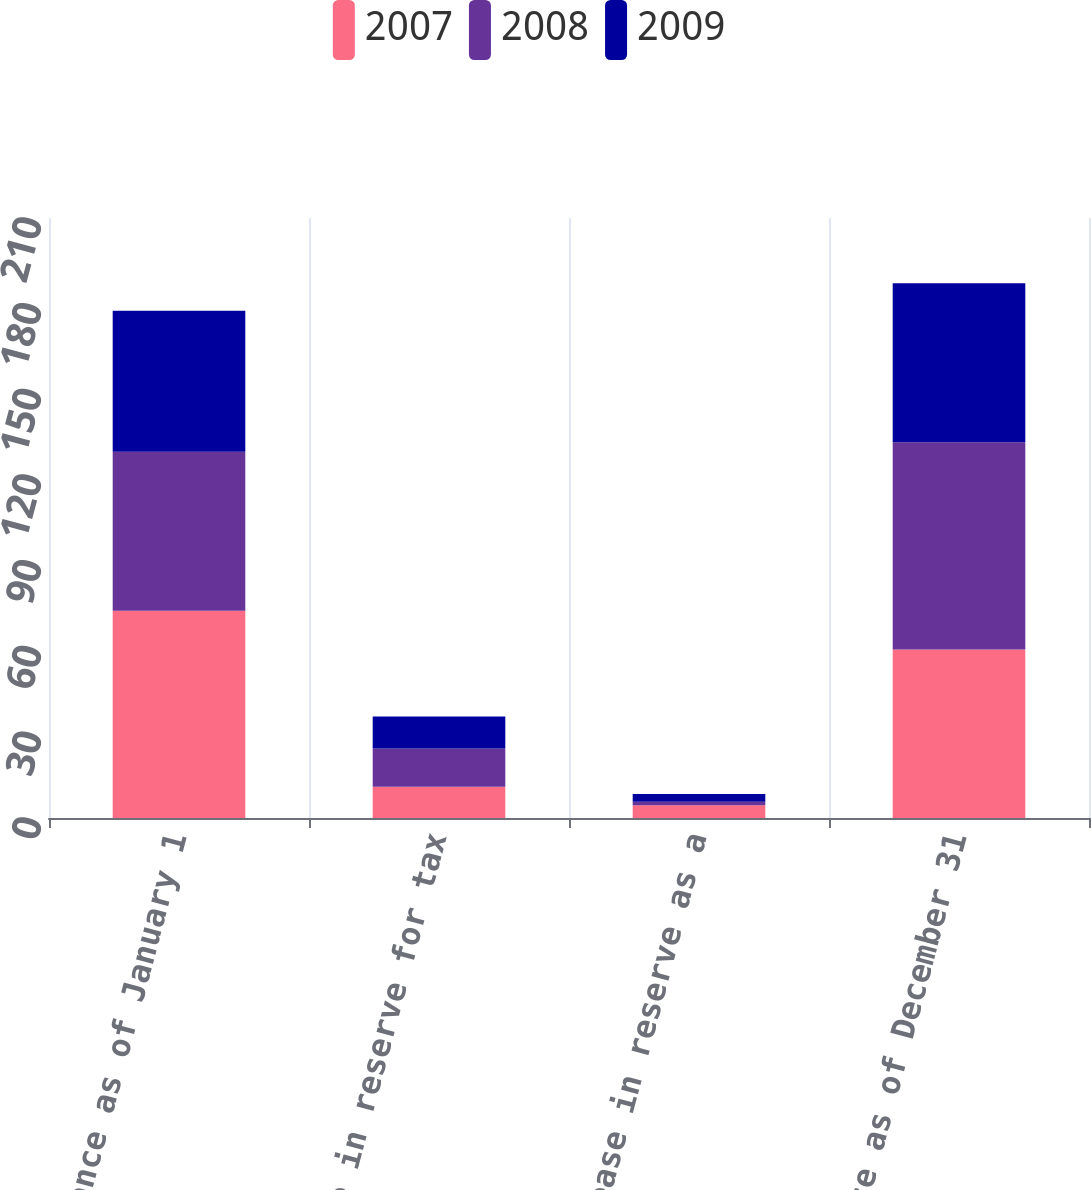Convert chart. <chart><loc_0><loc_0><loc_500><loc_500><stacked_bar_chart><ecel><fcel>Balance as of January 1<fcel>Increase in reserve for tax<fcel>Decrease in reserve as a<fcel>Balance as of December 31<nl><fcel>2007<fcel>72.5<fcel>10.9<fcel>4.5<fcel>59<nl><fcel>2008<fcel>55.7<fcel>13.4<fcel>1.2<fcel>72.5<nl><fcel>2009<fcel>49.3<fcel>11.2<fcel>2.7<fcel>55.7<nl></chart> 